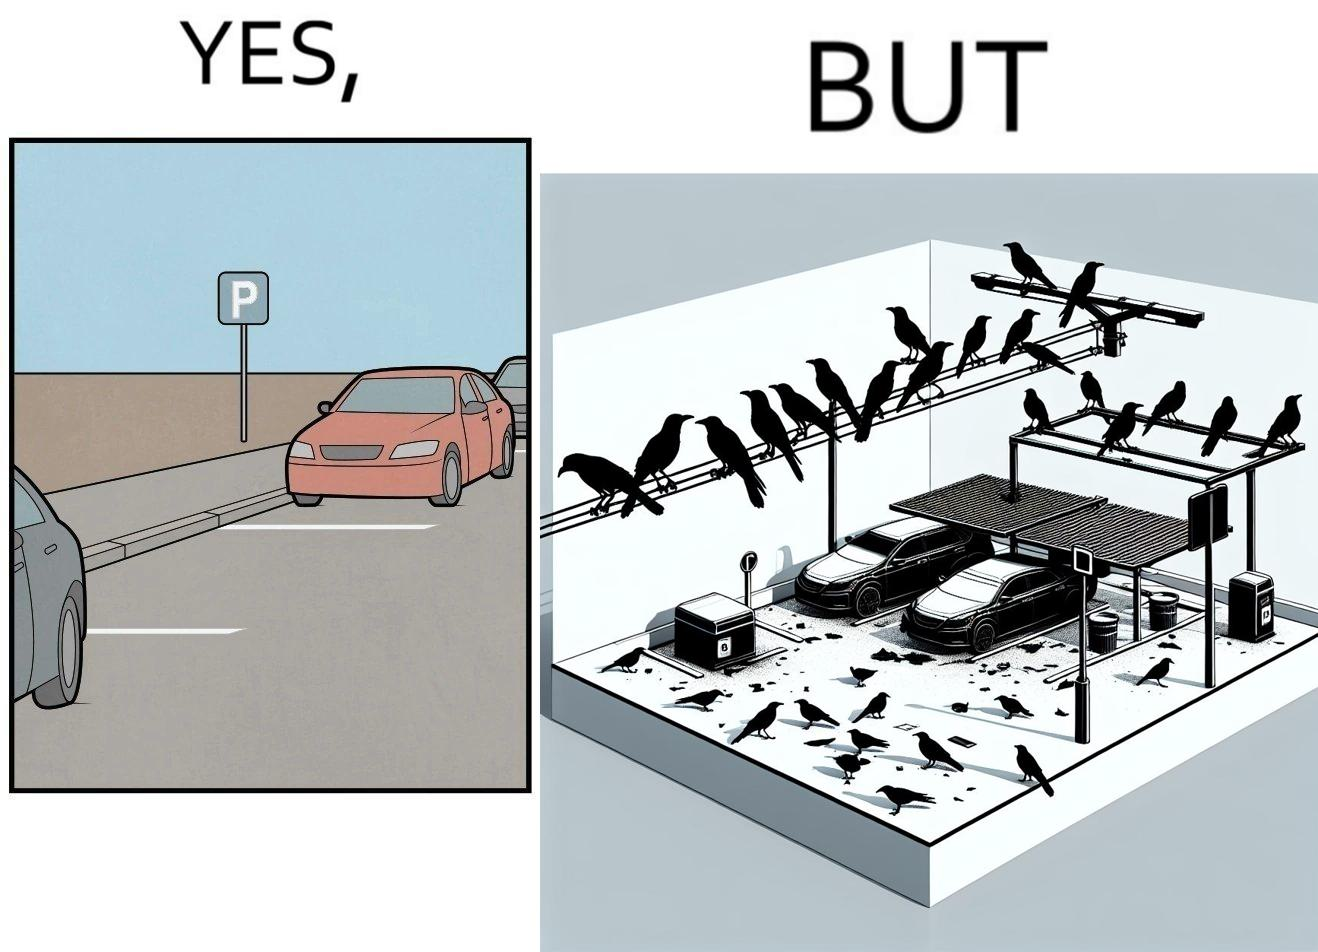Describe the contrast between the left and right parts of this image. In the left part of the image: There is a parking place where few cars are standing leaving a place in middle. In the right part of the image: Some crows are sitting on a wire which is above the parking area and the crows are making that place dirty. 